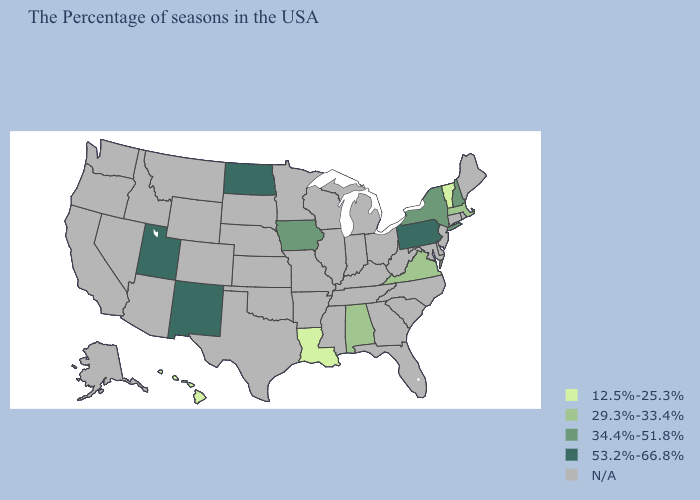What is the lowest value in the Northeast?
Give a very brief answer. 12.5%-25.3%. Does Iowa have the highest value in the USA?
Concise answer only. No. Among the states that border Arizona , which have the highest value?
Concise answer only. New Mexico, Utah. What is the value of Massachusetts?
Write a very short answer. 29.3%-33.4%. Among the states that border Rhode Island , which have the lowest value?
Answer briefly. Massachusetts. What is the value of Massachusetts?
Be succinct. 29.3%-33.4%. What is the value of New Jersey?
Short answer required. N/A. Does Utah have the lowest value in the West?
Short answer required. No. What is the value of Oklahoma?
Concise answer only. N/A. How many symbols are there in the legend?
Be succinct. 5. Which states have the lowest value in the Northeast?
Short answer required. Vermont. What is the value of Tennessee?
Concise answer only. N/A. 